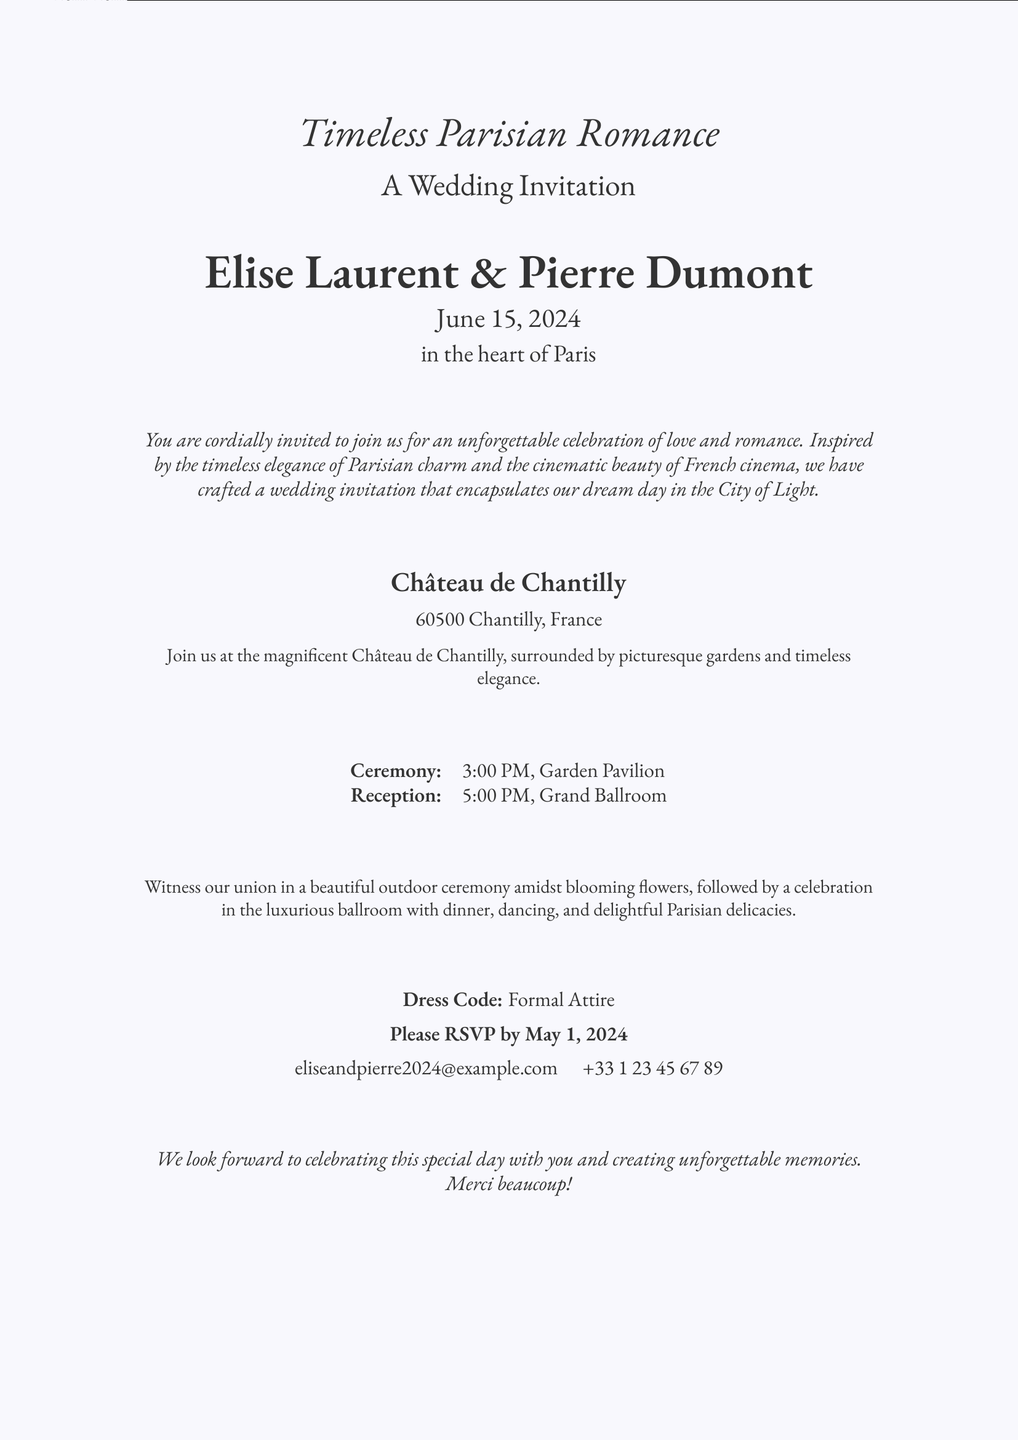what are the names of the couple? The invitation features the names of the couple prominently in the center.
Answer: Elise Laurent & Pierre Dumont what is the date of the wedding? The date is specified on the invitation.
Answer: June 15, 2024 where is the wedding location? The location is mentioned in a section dedicated to the venue.
Answer: Château de Chantilly what time does the ceremony start? The time for the ceremony is listed in a tabular format.
Answer: 3:00 PM what is the dress code for the wedding? The invitation includes a section on attire requirements.
Answer: Formal Attire what should guests do by May 1, 2024? The invitation specifies a requirement for guests.
Answer: RSVP what style influences the wedding invitation design? The invitation mentions an aesthetic style that inspired its design.
Answer: Art Nouveau what is referenced in the invitation to tie in cinematic influence? The document includes motifs that affect its overall theme.
Answer: film reel motifs what type of celebration is mentioned in the invitation? The invitation describes the nature of the event.
Answer: unforgettable celebration of love and romance 